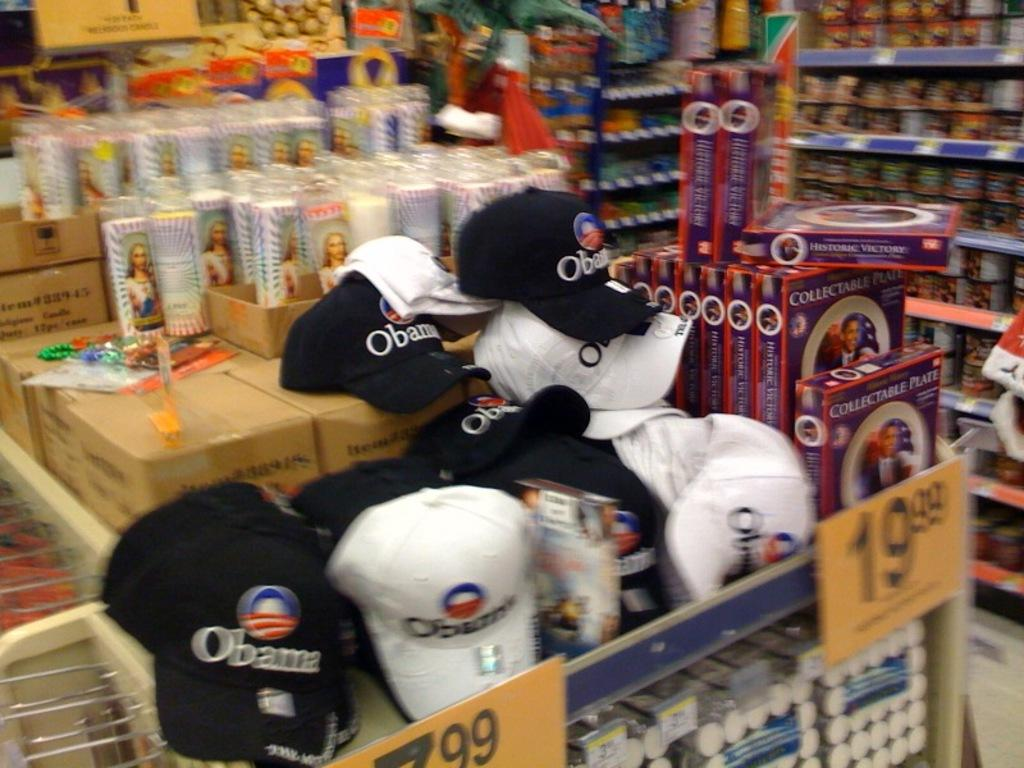<image>
Describe the image concisely. A stack of Obama and Jesus related merchandise on display at a store. 